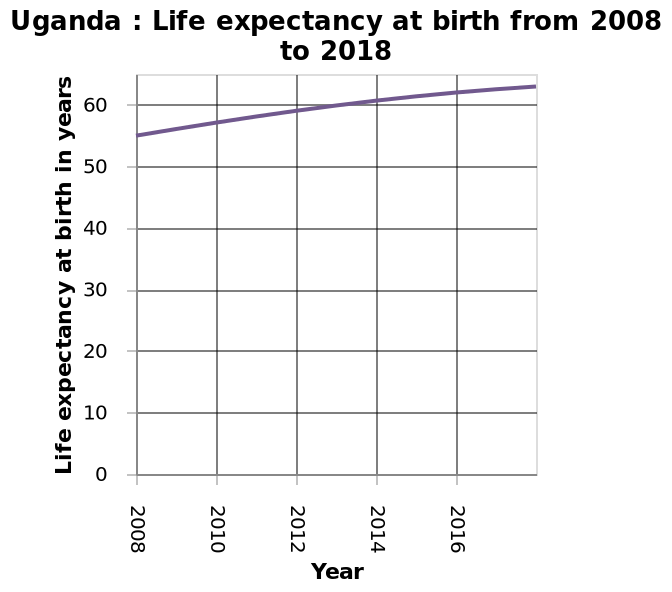<image>
please enumerates aspects of the construction of the chart Here a is a line plot called Uganda : Life expectancy at birth from 2008 to 2018. There is a linear scale from 0 to 60 on the y-axis, labeled Life expectancy at birth in years. On the x-axis, Year is measured with a linear scale with a minimum of 2008 and a maximum of 2016. What has been happening to life expectancy in Uganda since 2008?  Life expectancy in Uganda has been on the rise since 2008. 